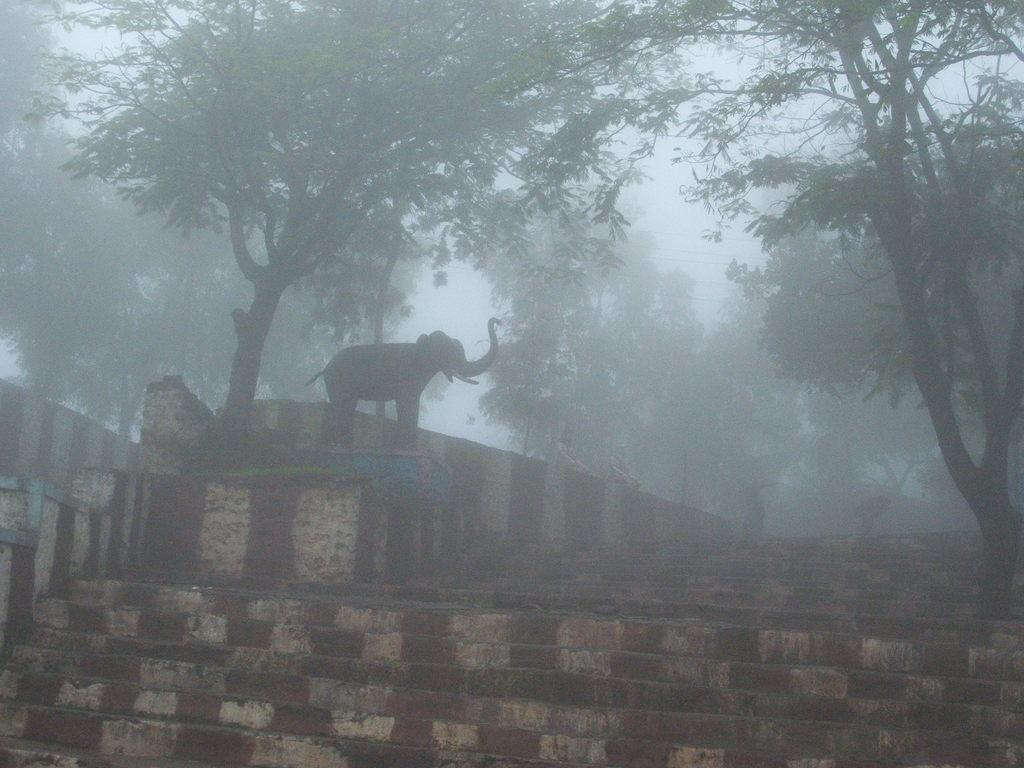What can be seen in the image that people use to move between different levels? There are steps in the image that people use to move between different levels. What animal is standing on the steps in the image? An elephant is standing on the steps in the image. What type of vegetation is visible behind the elephant? There are trees visible behind the elephant. What is visible in the background behind the trees? The sky is visible behind the trees. Can you tell me how the elephant is being punished in the image? There is no indication in the image that the elephant is being punished; it is simply standing on the steps. What type of can is visible in the image? There is no can present in the image. 